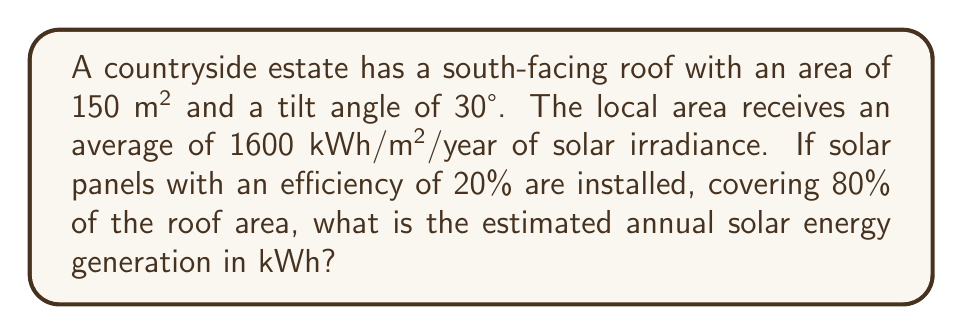Show me your answer to this math problem. To solve this problem, we'll follow these steps:

1. Calculate the effective roof area for solar panels:
   $$A_{effective} = 150 \text{ m}^2 \times 0.80 = 120 \text{ m}^2$$

2. Account for the roof tilt angle:
   The optimal tilt angle for solar panels is approximately equal to the latitude of the location. A 30° tilt is close to optimal for many locations, so we'll assume no additional correction factor is needed.

3. Calculate the annual solar energy incident on the panels:
   $$E_{incident} = 1600 \text{ kWh/m}^2/\text{year} \times 120 \text{ m}^2 = 192,000 \text{ kWh/year}$$

4. Apply the solar panel efficiency:
   $$E_{generated} = E_{incident} \times \text{efficiency}$$
   $$E_{generated} = 192,000 \text{ kWh/year} \times 0.20 = 38,400 \text{ kWh/year}$$

Therefore, the estimated annual solar energy generation is 38,400 kWh.
Answer: 38,400 kWh/year 